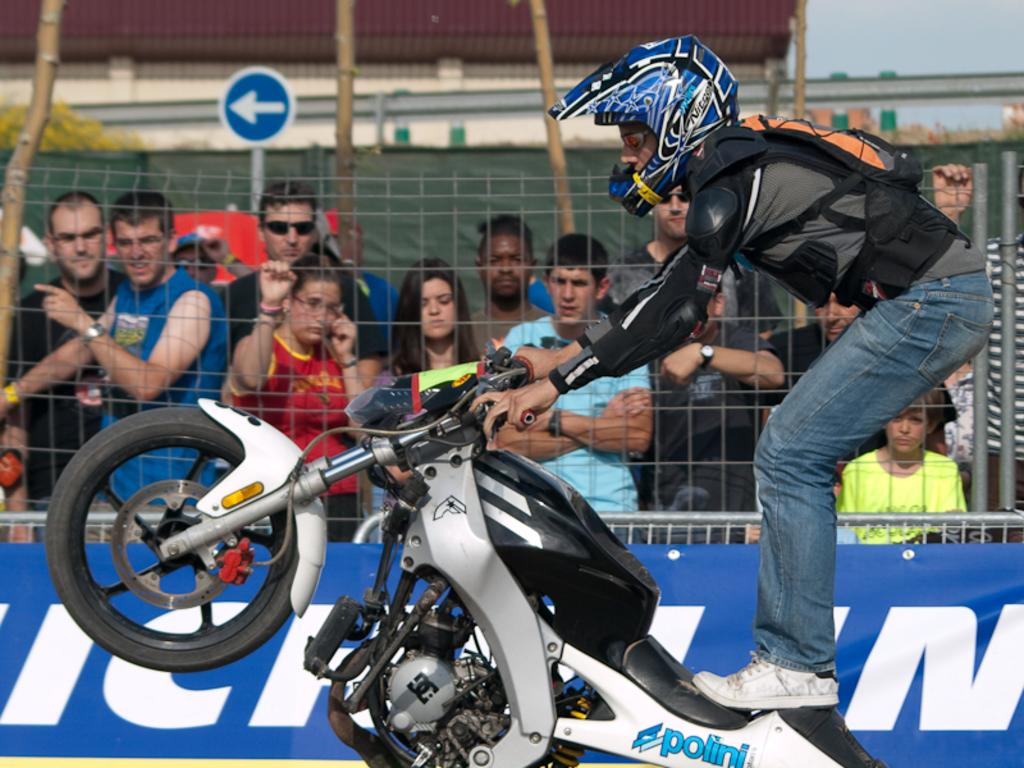What is the person in the image doing? The person is standing on a bike in the image. What can be seen in the background of the image? There is a fence visible in the background of the image. Are there any other people in the image? Yes, there are other persons in the background of the image. What type of toothbrush is the person using while standing on the bike? There is no toothbrush present in the image, and the person is not using one while standing on the bike. 